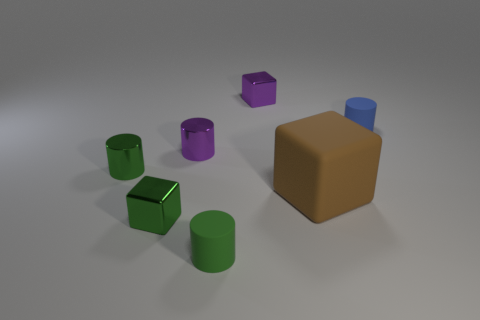Add 2 big gray matte spheres. How many objects exist? 9 Subtract all cylinders. How many objects are left? 3 Add 6 purple metallic cylinders. How many purple metallic cylinders are left? 7 Add 5 brown cubes. How many brown cubes exist? 6 Subtract 2 green cylinders. How many objects are left? 5 Subtract all big blue metallic spheres. Subtract all purple metallic objects. How many objects are left? 5 